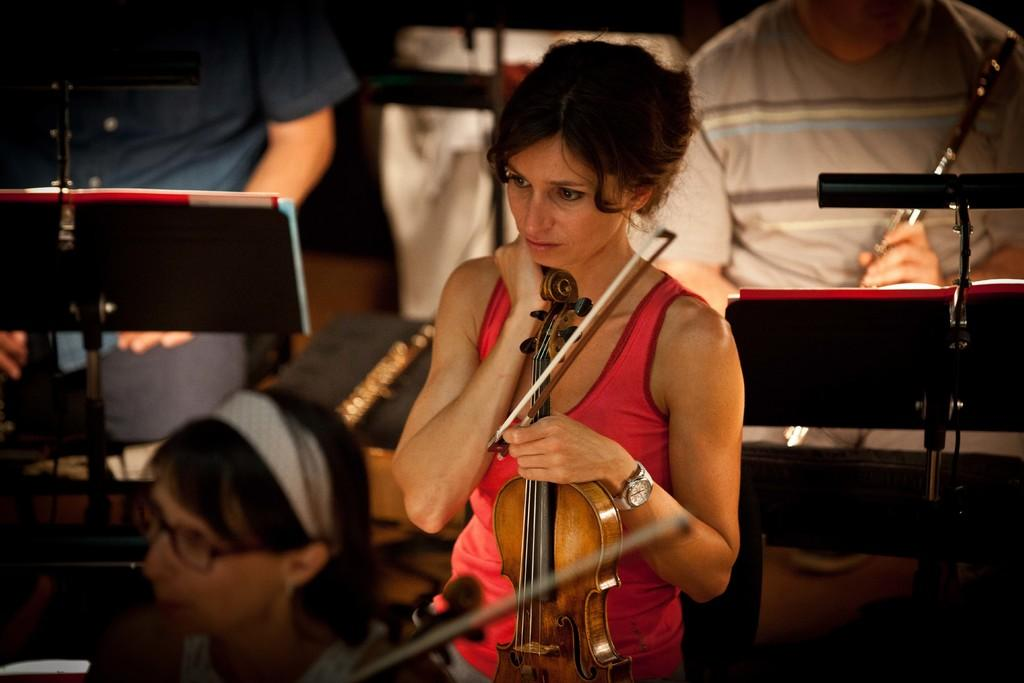What is the main subject of the image? The main subject of the image is a woman. What is the woman doing in the image? The woman is holding a musical instrument. What is the woman's posture in the image? The woman is standing. Are there any other people in the image? Yes, there are other persons in the image. What are these other persons doing? These other persons are holding musical instruments. How do the waves affect the musical instruments in the image? There are no waves present in the image, so they cannot affect the musical instruments. What type of roll can be seen in the image? There is no roll present in the image. 